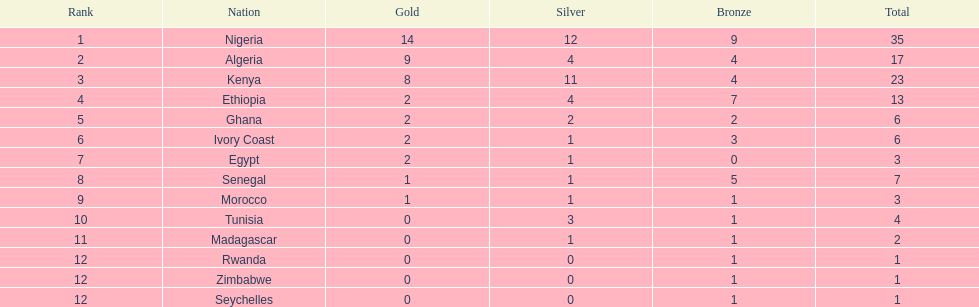The team before algeria Nigeria. Write the full table. {'header': ['Rank', 'Nation', 'Gold', 'Silver', 'Bronze', 'Total'], 'rows': [['1', 'Nigeria', '14', '12', '9', '35'], ['2', 'Algeria', '9', '4', '4', '17'], ['3', 'Kenya', '8', '11', '4', '23'], ['4', 'Ethiopia', '2', '4', '7', '13'], ['5', 'Ghana', '2', '2', '2', '6'], ['6', 'Ivory Coast', '2', '1', '3', '6'], ['7', 'Egypt', '2', '1', '0', '3'], ['8', 'Senegal', '1', '1', '5', '7'], ['9', 'Morocco', '1', '1', '1', '3'], ['10', 'Tunisia', '0', '3', '1', '4'], ['11', 'Madagascar', '0', '1', '1', '2'], ['12', 'Rwanda', '0', '0', '1', '1'], ['12', 'Zimbabwe', '0', '0', '1', '1'], ['12', 'Seychelles', '0', '0', '1', '1']]} 